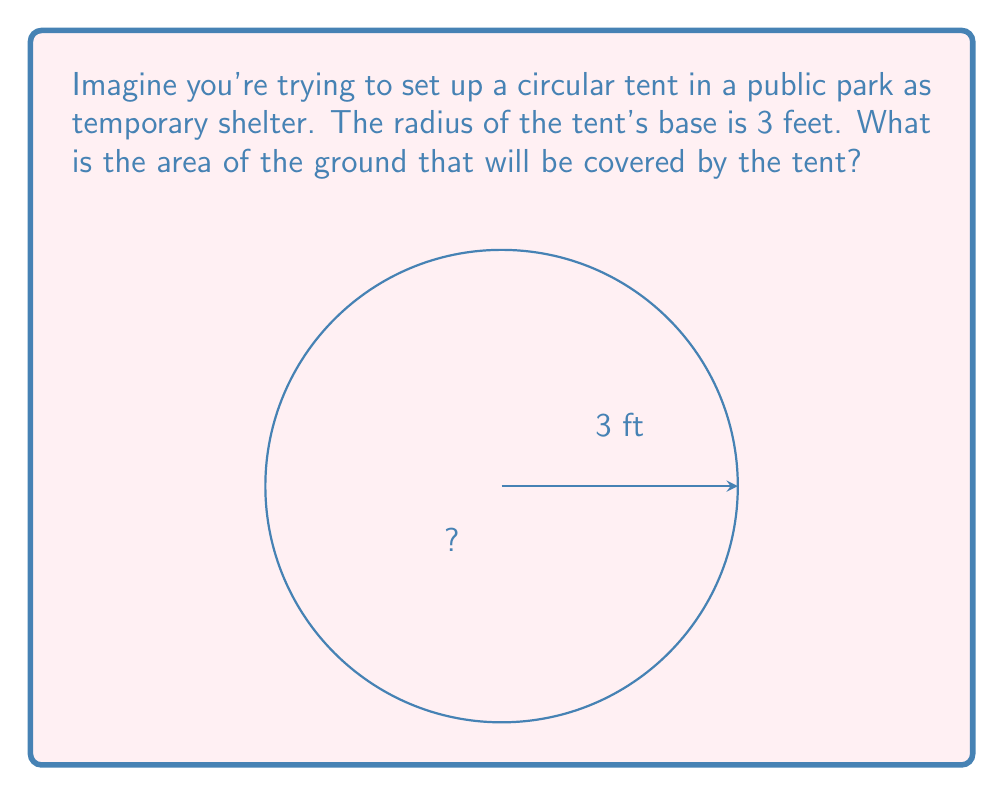Give your solution to this math problem. Let's approach this step-by-step:

1) The formula for the area of a circle is:
   $$A = \pi r^2$$
   where $A$ is the area and $r$ is the radius.

2) We're given that the radius is 3 feet.

3) Let's substitute this into our formula:
   $$A = \pi (3)^2$$

4) Simplify the exponent:
   $$A = \pi (9)$$

5) Now, we can calculate this:
   $$A = 9\pi \approx 28.27 \text{ square feet}$$

6) We typically leave the answer in terms of $\pi$ for exact calculations, but we've also provided the decimal approximation for practical use.
Answer: $9\pi$ square feet 